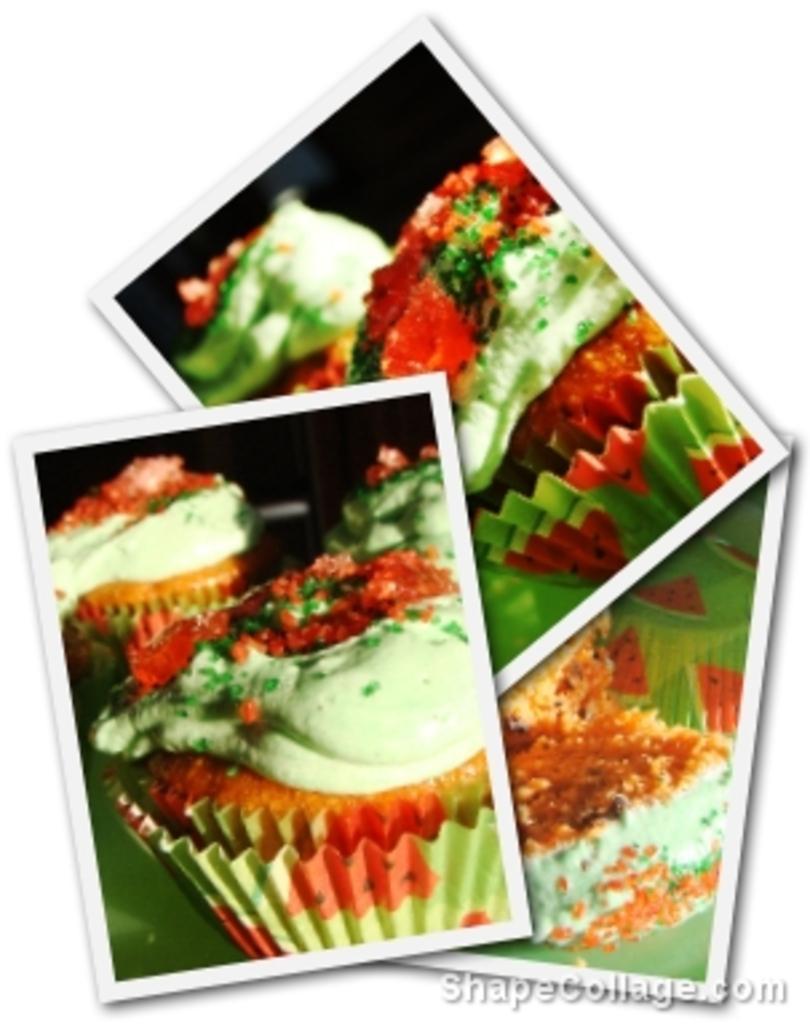Please provide a concise description of this image. In this picture, we can see few photographs. In these photographs, we can see food items. On the right side bottom corner, there is a watermark in the image. 